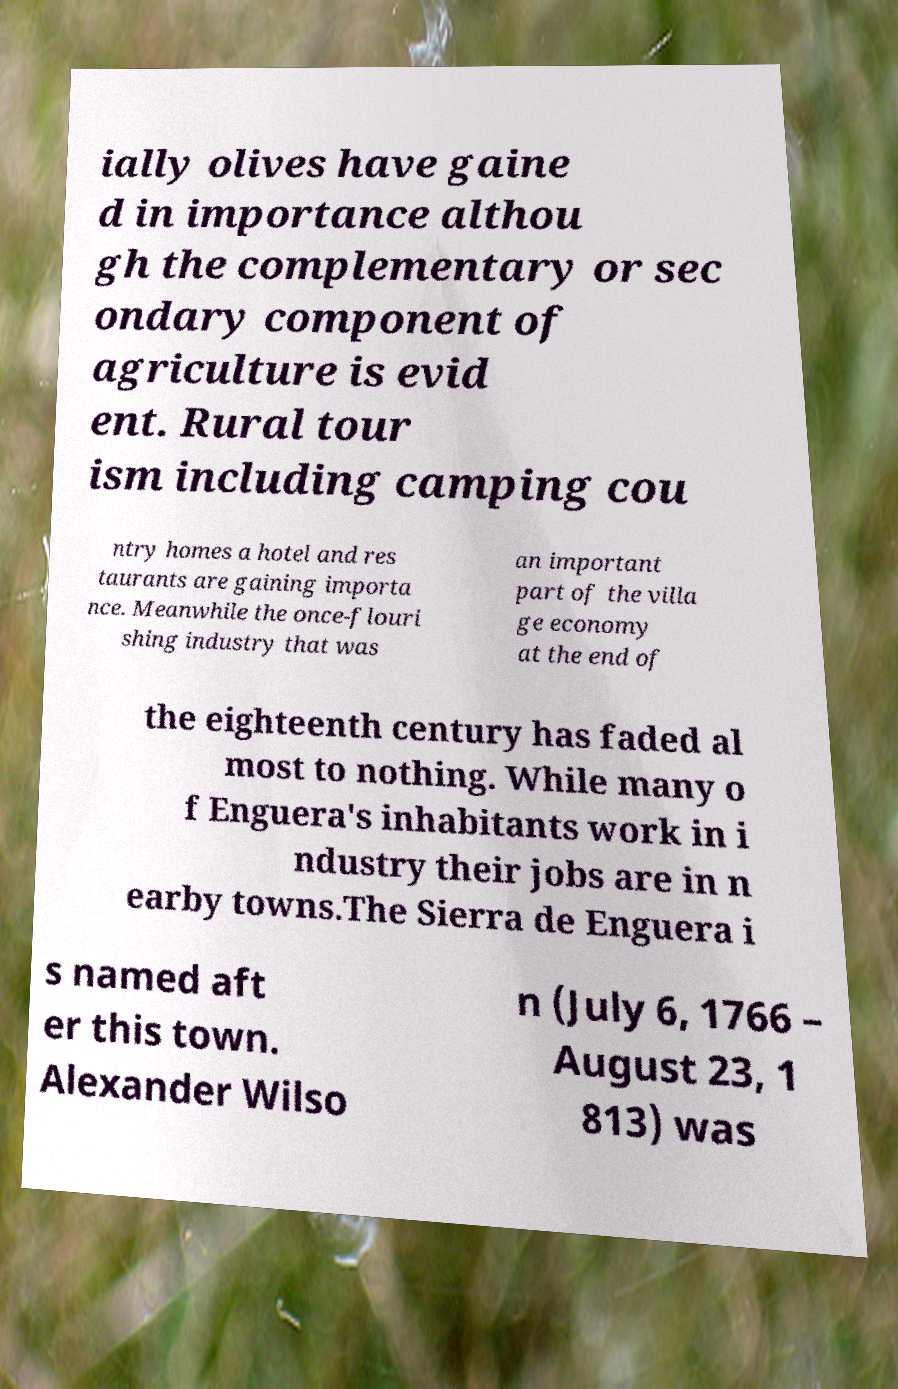Please read and relay the text visible in this image. What does it say? ially olives have gaine d in importance althou gh the complementary or sec ondary component of agriculture is evid ent. Rural tour ism including camping cou ntry homes a hotel and res taurants are gaining importa nce. Meanwhile the once-flouri shing industry that was an important part of the villa ge economy at the end of the eighteenth century has faded al most to nothing. While many o f Enguera's inhabitants work in i ndustry their jobs are in n earby towns.The Sierra de Enguera i s named aft er this town. Alexander Wilso n (July 6, 1766 – August 23, 1 813) was 